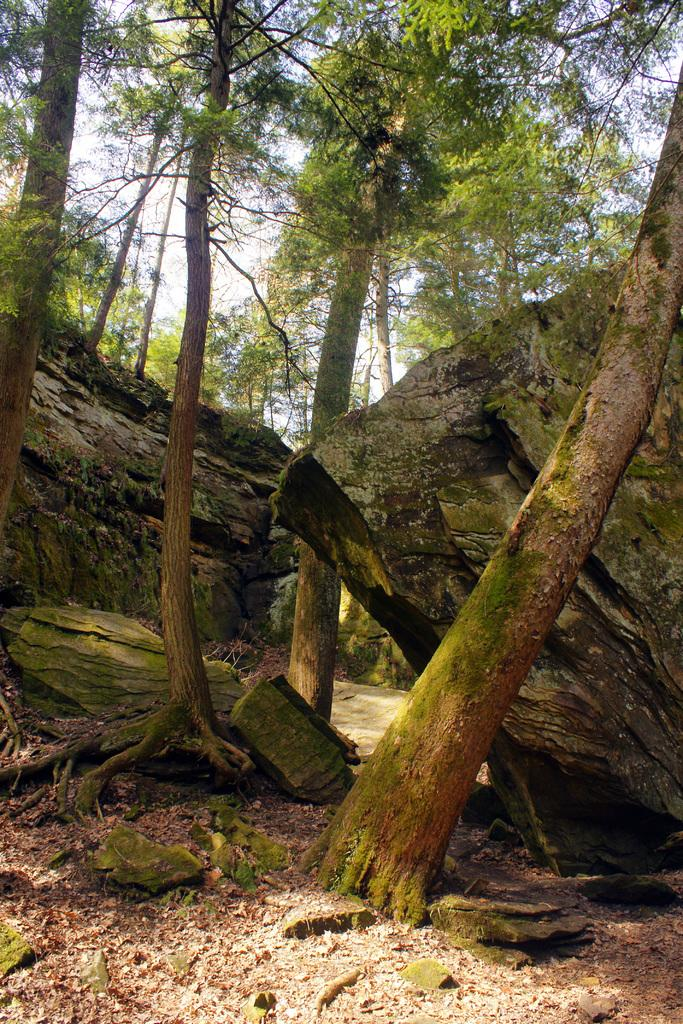What type of natural elements can be seen in the image? There are rocks and trees in the image. What is visible in the background of the image? The sky is visible in the background of the image. What type of beast can be seen roaming among the rocks in the image? There is no beast present in the image; it only features rocks, trees, and the sky. 